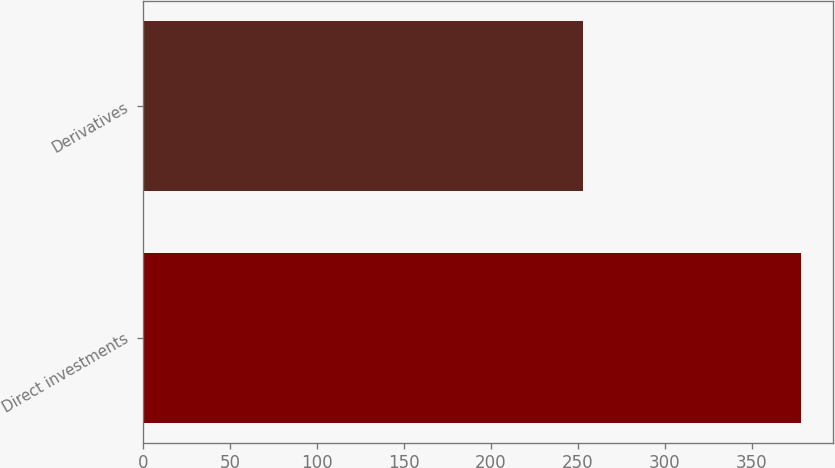Convert chart. <chart><loc_0><loc_0><loc_500><loc_500><bar_chart><fcel>Direct investments<fcel>Derivatives<nl><fcel>378<fcel>253<nl></chart> 